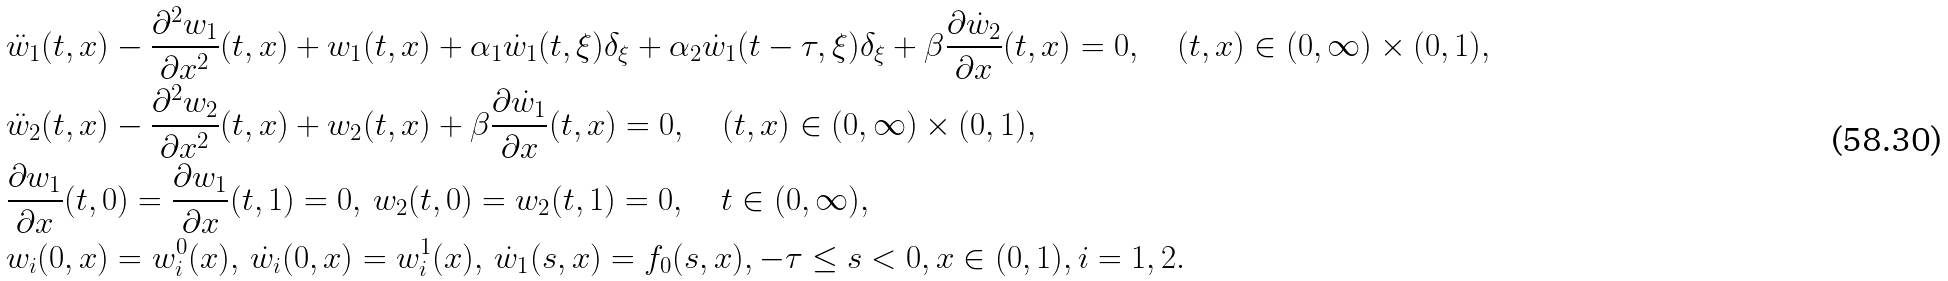<formula> <loc_0><loc_0><loc_500><loc_500>& \ddot { w } _ { 1 } ( t , x ) - \frac { \partial ^ { 2 } w _ { 1 } } { \partial x ^ { 2 } } ( t , x ) + w _ { 1 } ( t , x ) + \alpha _ { 1 } \dot { w } _ { 1 } ( t , \xi ) \delta _ { \xi } + \alpha _ { 2 } \dot { w } _ { 1 } ( t - \tau , \xi ) \delta _ { \xi } + \beta \frac { \partial \dot { w } _ { 2 } } { \partial x } ( t , x ) = 0 , \quad ( t , x ) \in ( 0 , \infty ) \times ( 0 , 1 ) , \\ & \ddot { w } _ { 2 } ( t , x ) - \frac { \partial ^ { 2 } w _ { 2 } } { \partial x ^ { 2 } } ( t , x ) + w _ { 2 } ( t , x ) + \beta \frac { \partial \dot { w } _ { 1 } } { \partial x } ( t , x ) = 0 , \quad ( t , x ) \in ( 0 , \infty ) \times ( 0 , 1 ) , \\ & \frac { \partial w _ { 1 } } { \partial x } ( t , 0 ) = \frac { \partial w _ { 1 } } { \partial x } ( t , 1 ) = 0 , \, w _ { 2 } ( t , 0 ) = w _ { 2 } ( t , 1 ) = 0 , \quad t \in ( 0 , \infty ) , \\ & w _ { i } ( 0 , x ) = w _ { i } ^ { 0 } ( x ) , \, \dot { w } _ { i } ( 0 , x ) = w _ { i } ^ { 1 } ( x ) , \, \dot { w } _ { 1 } ( s , x ) = f _ { 0 } ( s , x ) , - \tau \leq s < 0 , x \in ( 0 , 1 ) , i = 1 , 2 .</formula> 